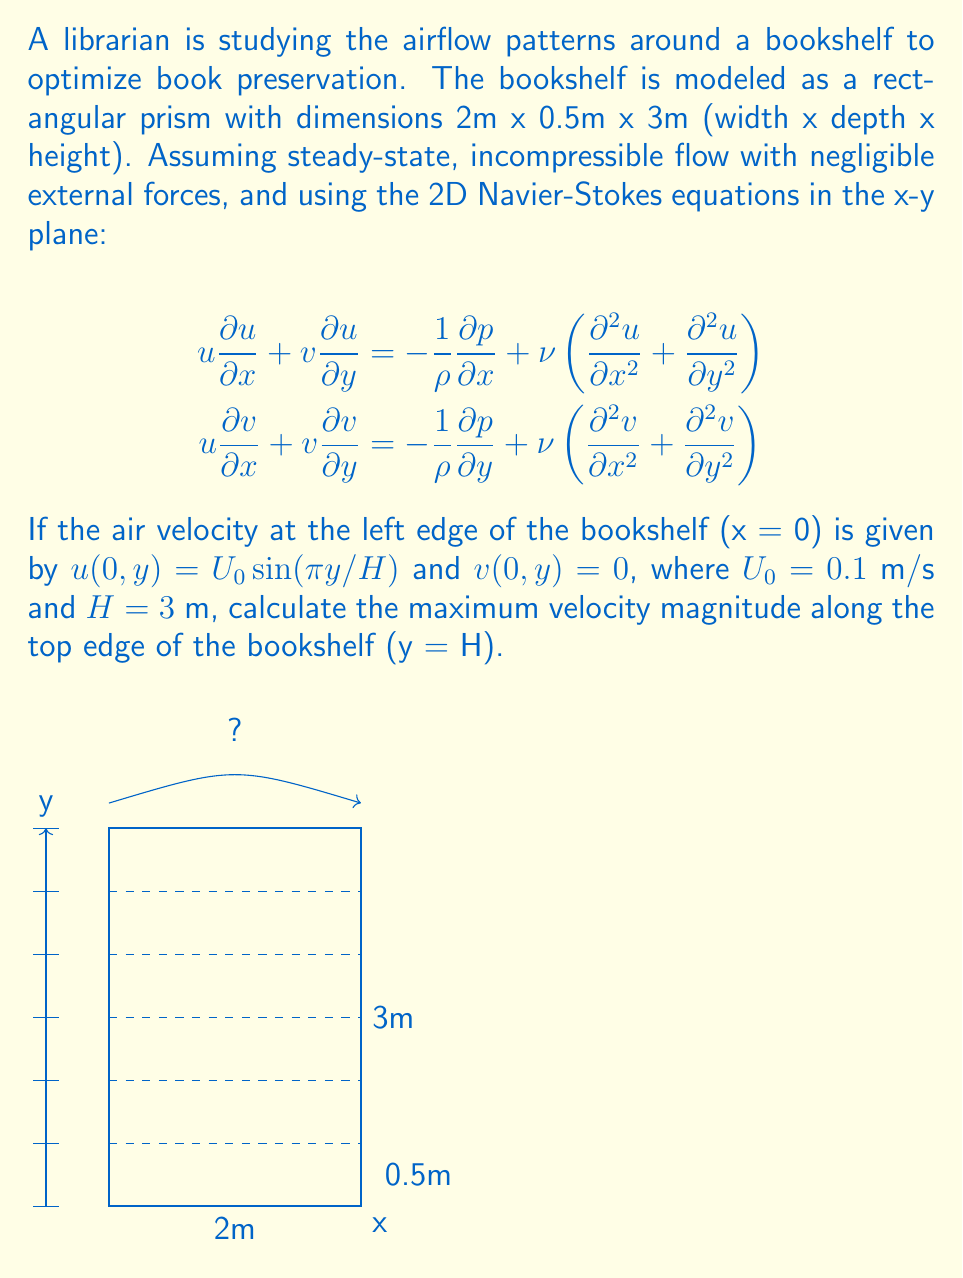Teach me how to tackle this problem. To solve this problem, we'll follow these steps:

1) First, we need to understand the given information:
   - The flow is steady-state and incompressible
   - We're using 2D Navier-Stokes equations in the x-y plane
   - The initial velocity profile at x = 0 is given

2) The velocity profile at x = 0 is:
   $u(0,y) = U_0\sin(\pi y/H)$ and $v(0,y) = 0$
   where $U_0 = 0.1$ m/s and $H = 3$ m

3) To find the maximum velocity magnitude along the top edge (y = H), we need to consider both u and v components.

4) At y = H, the initial u velocity (at x = 0) is:
   $u(0,H) = U_0\sin(\pi H/H) = U_0\sin(\pi) = 0$

5) As the flow develops along the x-direction, the velocity profile will change due to viscous effects and pressure gradients. However, without solving the full Navier-Stokes equations (which is beyond the scope of this problem), we can't determine the exact velocity profile at all points.

6) What we can say is that the maximum velocity magnitude along the top edge will occur where the sum of the squares of u and v components is largest:
   $V_{max} = \max\sqrt{u^2 + v^2}$ for $0 \leq x \leq 2$ at $y = H$

7) Given the initial conditions and the no-slip condition at the bookshelf surface, we can estimate that the maximum velocity will be less than or equal to the maximum initial velocity, which occurs at y = H/2:
   $V_{max} \leq U_0\sin(\pi/2) = 0.1$ m/s

8) Therefore, we can conclude that the maximum velocity magnitude along the top edge of the bookshelf will be between 0 and 0.1 m/s, but the exact value would require solving the full Navier-Stokes equations with appropriate boundary conditions.
Answer: $0 < V_{max} \leq 0.1$ m/s 